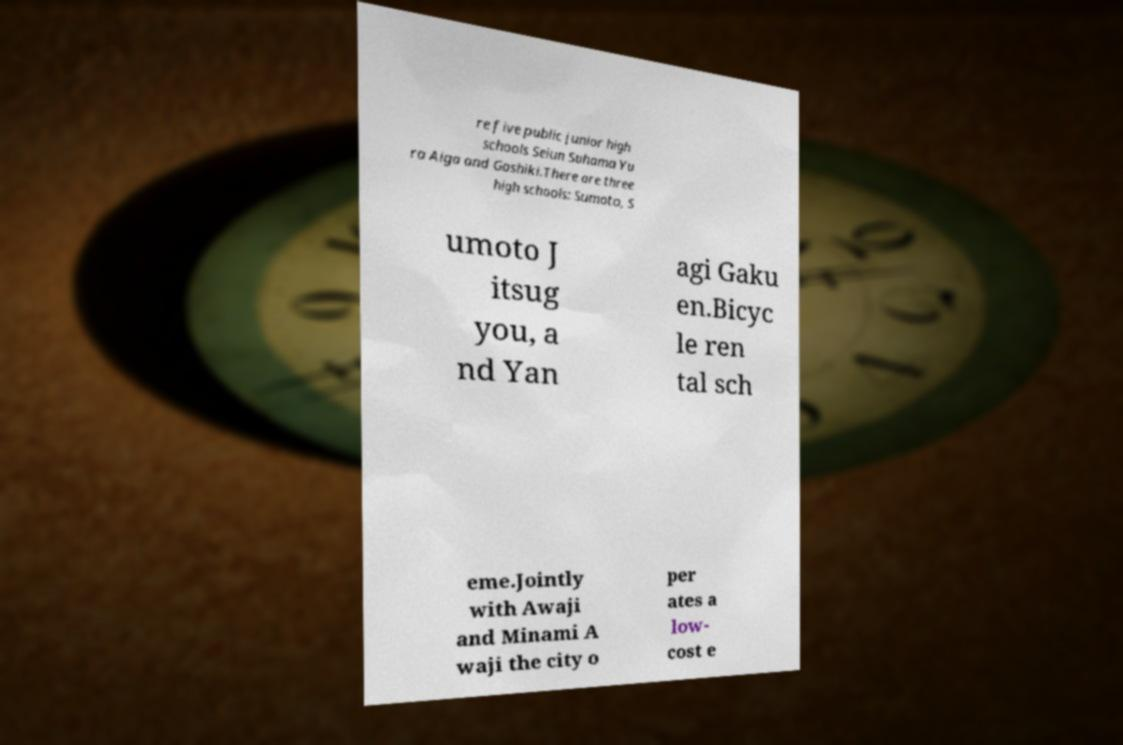Please read and relay the text visible in this image. What does it say? re five public junior high schools Seiun Suhama Yu ra Aiga and Goshiki.There are three high schools: Sumoto, S umoto J itsug you, a nd Yan agi Gaku en.Bicyc le ren tal sch eme.Jointly with Awaji and Minami A waji the city o per ates a low- cost e 